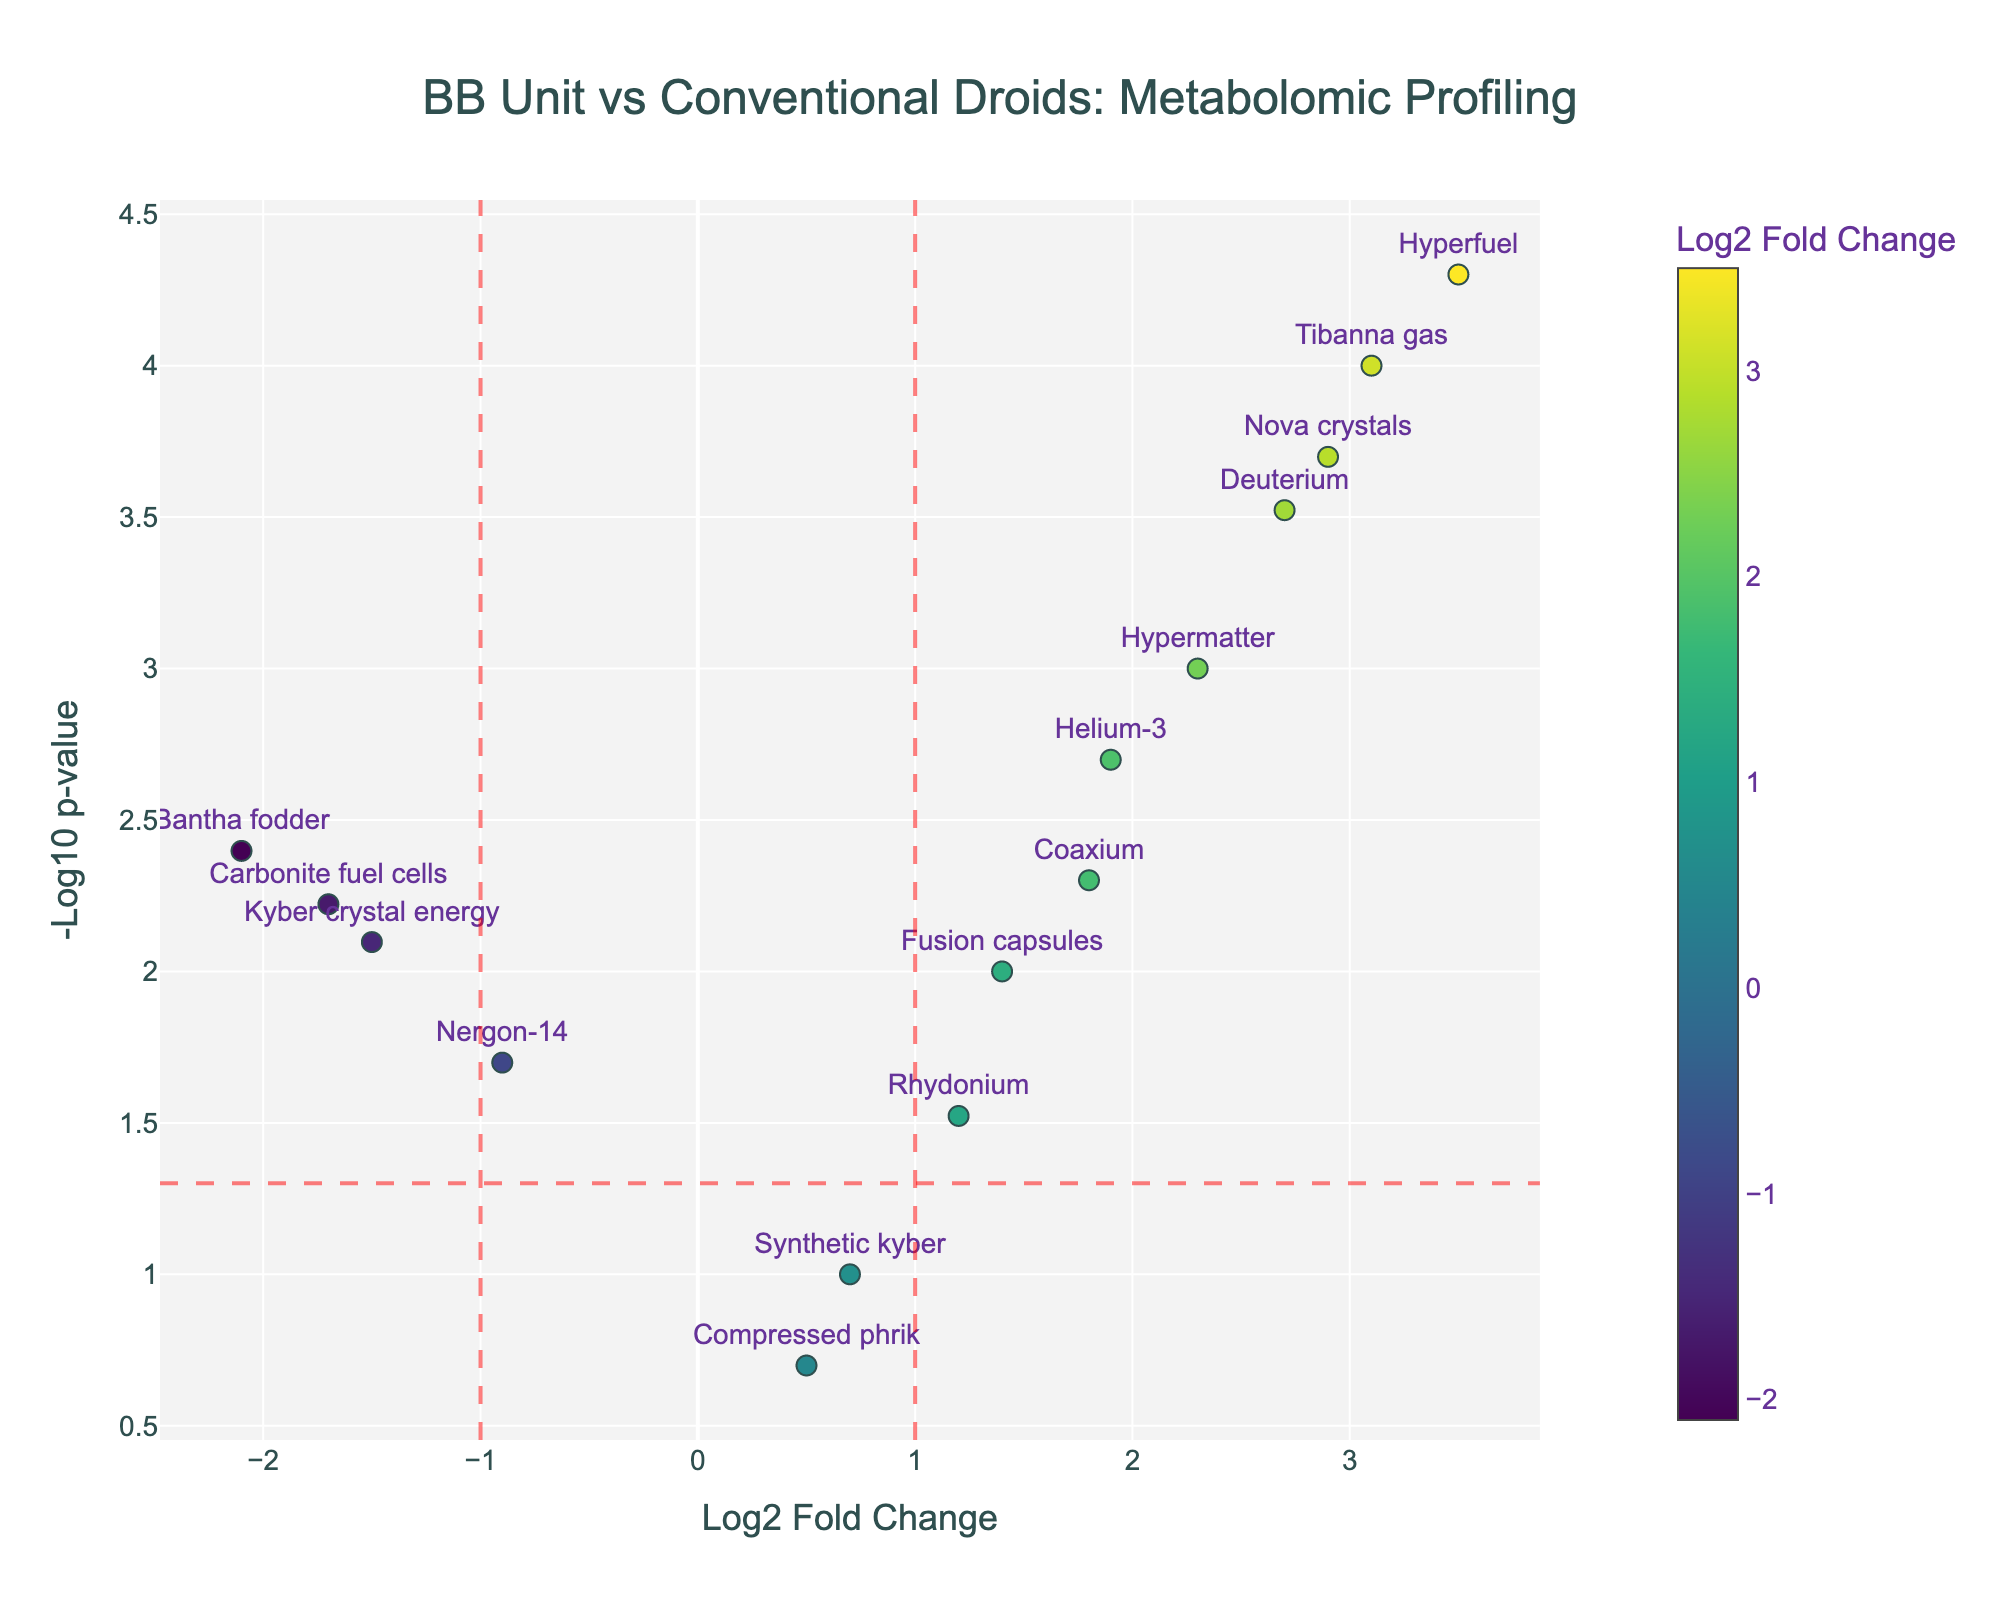What is the title of the plot? The title is displayed at the top of the figure, indicating the main theme or subject of the plot. Here, it is written in a larger and centered text at the top of the plot.
Answer: BB Unit vs Conventional Droids: Metabolomic Profiling How many metabolites have a Log2 Fold Change greater than 1 and a p-value less than 0.05? To answer this, we count the data points to the right of the vertical red dashed line at x=1 and above the horizontal red dashed line at y=-log10(0.05).
Answer: 7 Which metabolite has the highest Log2 Fold Change? The highest Log2 Fold Change is represented by the point farthest to the right on the x-axis. Checking the labels, it corresponds to 'Hyperfuel'.
Answer: Hyperfuel What is the color of the data points, and how is it determined? The colors of the data points range based on the Log2 Fold Change values, according to a viridis colorscale shown by the colorbar on the right side of the plot. The higher the Log2 Fold Change, the darker the color.
Answer: Viridis colorscale What are the coordinates (Log2 Fold Change, -Log10 p-value) of 'Bantha fodder'? To find this, locate 'Bantha fodder' labeled data point and read the x and y values directly from the axis.
Answer: (-2.1, 2.4) Which metabolites are considered statistically significant (p-value < 0.05) but have a Log2 Fold Change between -1 and 1? These metabolites are above the horizontal red dashed line at y=-log10(0.05) and between the two vertical red dashed lines at x=-1 and x=1. Identifying such points from the plot gives the required metabolites.
Answer: Rhydonium, Kyber crystal energy, Bantha fodder, Fusion capsules How many metabolites show a downregulated change (negative Log2 Fold Change) with statistical significance (p-value < 0.05)? Downregulated changes are represented by points to the left of x=0. Count these points that are also above y=-log10(0.05).
Answer: 3 Which metabolite has the smallest p-value, and what is its Log2 Fold Change? The smallest p-value corresponds to the highest -Log10 p-value (y-axis). Locating this point and reading its Log2 Fold Change gives the answer.
Answer: Hyperfuel, 3.5 What do the horizontal and vertical red dashed lines represent? The horizontal red dashed line at y=-log10(0.05) represents the significance threshold (p-value=0.05), and the vertical red dashed lines at x=1 and x=-1 represent thresholds for Log2 Fold Change.
Answer: p-value threshold and Log2 Fold Change thresholds 